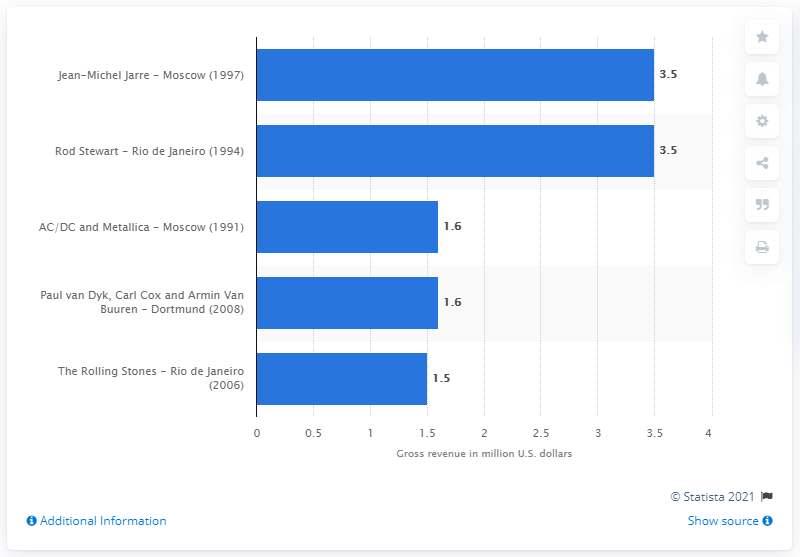Indicate a few pertinent items in this graphic. Jean-Michel Jarre's concert in 1997 was attended by 3.5 people. 